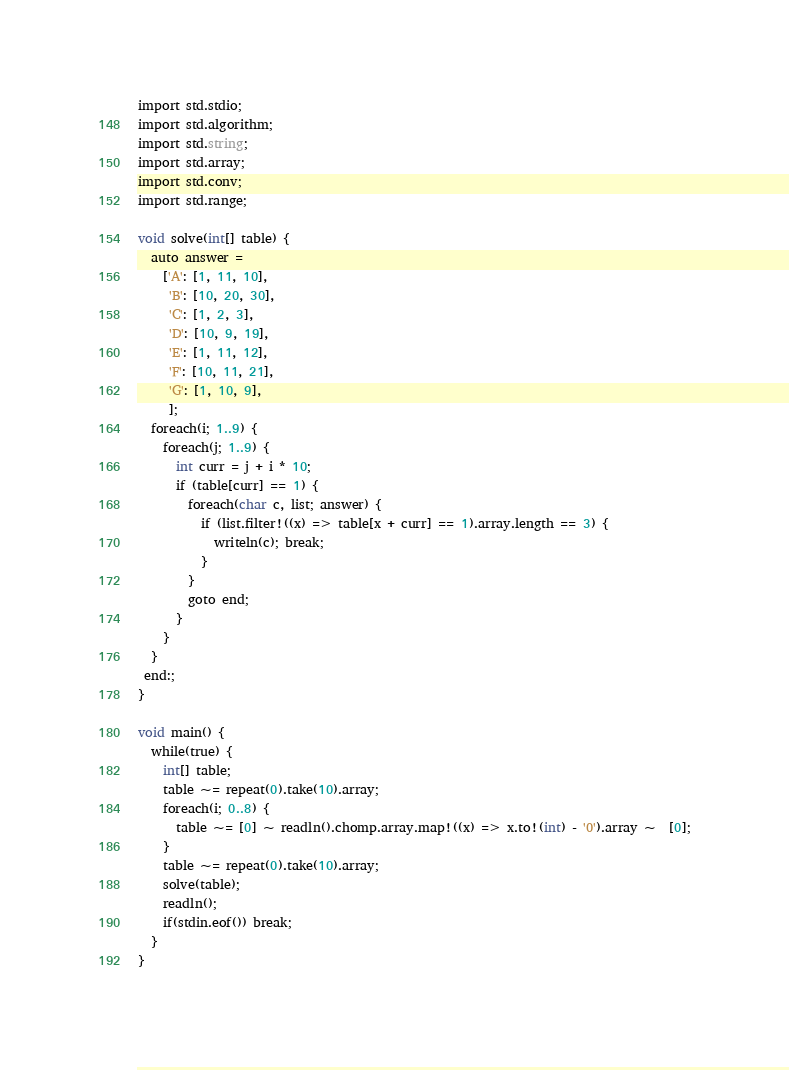<code> <loc_0><loc_0><loc_500><loc_500><_D_>
import std.stdio;
import std.algorithm;
import std.string;
import std.array;
import std.conv;
import std.range;

void solve(int[] table) {
  auto answer =
    ['A': [1, 11, 10],
     'B': [10, 20, 30],
     'C': [1, 2, 3],
     'D': [10, 9, 19],
     'E': [1, 11, 12],
     'F': [10, 11, 21],
     'G': [1, 10, 9],
     ];
  foreach(i; 1..9) {
    foreach(j; 1..9) {
      int curr = j + i * 10;
      if (table[curr] == 1) {
        foreach(char c, list; answer) {
          if (list.filter!((x) => table[x + curr] == 1).array.length == 3) {
            writeln(c); break;
          }
        }
        goto end;
      }
    }
  }
 end:;
}

void main() {
  while(true) {
    int[] table;
    table ~= repeat(0).take(10).array;
    foreach(i; 0..8) {
      table ~= [0] ~ readln().chomp.array.map!((x) => x.to!(int) - '0').array ~  [0];
    }
    table ~= repeat(0).take(10).array;
    solve(table);
    readln();
    if(stdin.eof()) break;
  }
}</code> 